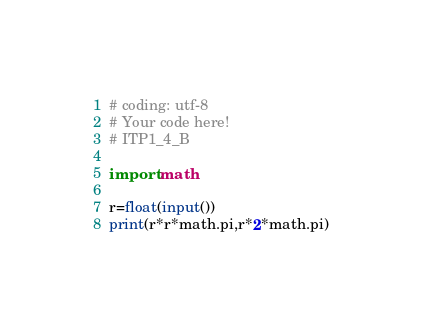<code> <loc_0><loc_0><loc_500><loc_500><_Python_># coding: utf-8
# Your code here!
# ITP1_4_B

import math

r=float(input())
print(r*r*math.pi,r*2*math.pi)
</code> 